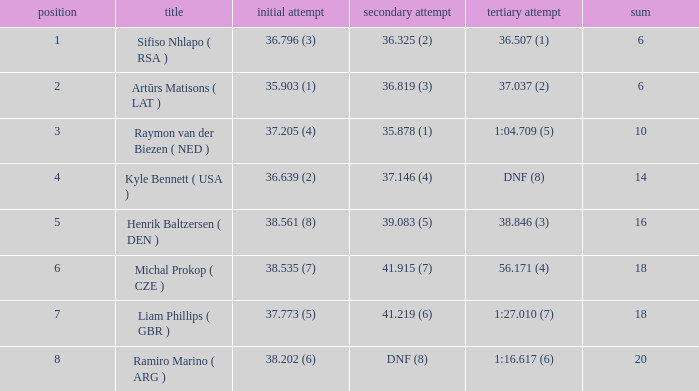Which 3rd run has rank of 8? 1:16.617 (6). 